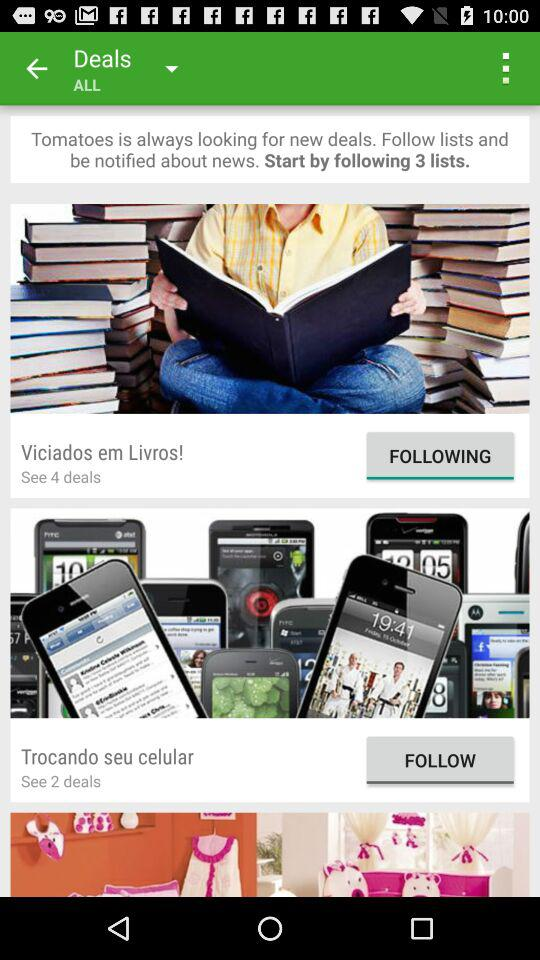How many deals are there on "Trocando seu celular"? There are 2 deals. 